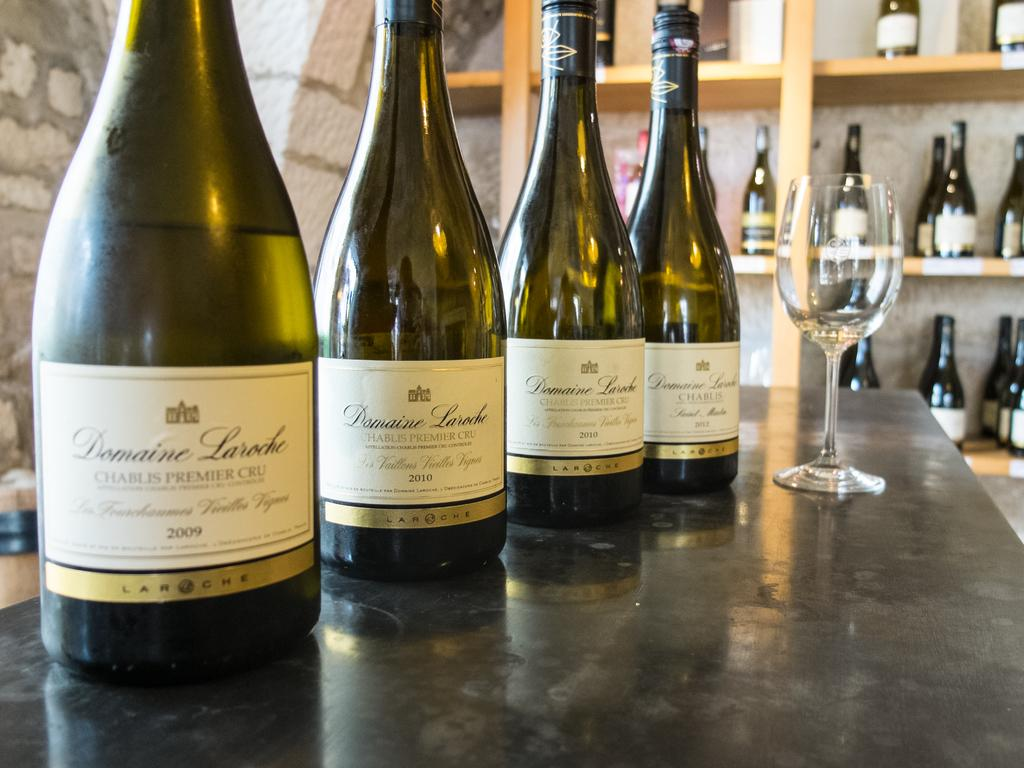What type of containers are visible in the image? There are four glass bottles with labels in the image. What other type of glassware is present in the image? A wine glass is present in the image. Where are the objects placed in the image? The objects are placed on a table. What can be seen in the background of the image? There are bottles arranged in a rack in the background of the image. What type of cave is visible in the image? There is no cave present in the image; it features glass bottles, a wine glass, and a table. 